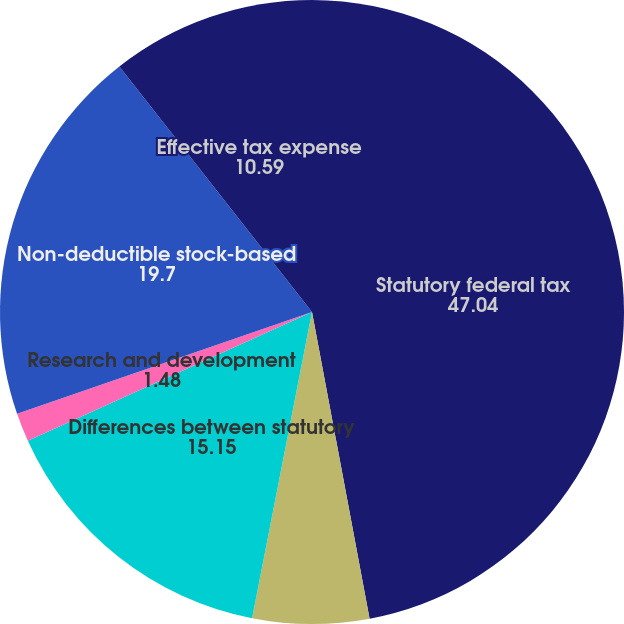Convert chart. <chart><loc_0><loc_0><loc_500><loc_500><pie_chart><fcel>Statutory federal tax<fcel>State taxes net of federal<fcel>Differences between statutory<fcel>Research and development<fcel>Non-deductible stock-based<fcel>Effective tax expense<nl><fcel>47.04%<fcel>6.03%<fcel>15.15%<fcel>1.48%<fcel>19.7%<fcel>10.59%<nl></chart> 